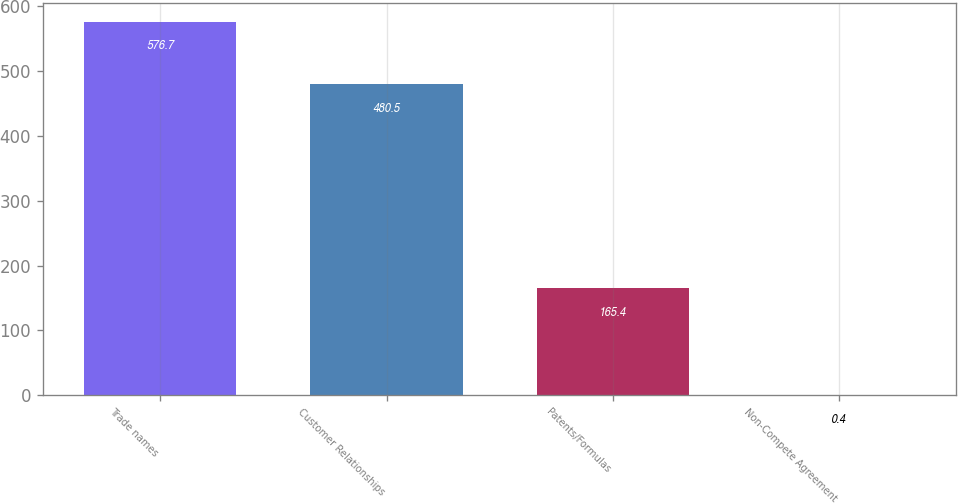Convert chart. <chart><loc_0><loc_0><loc_500><loc_500><bar_chart><fcel>Trade names<fcel>Customer Relationships<fcel>Patents/Formulas<fcel>Non-Compete Agreement<nl><fcel>576.7<fcel>480.5<fcel>165.4<fcel>0.4<nl></chart> 